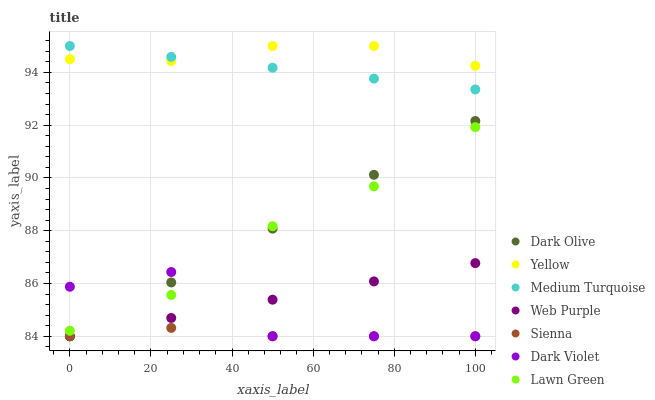Does Sienna have the minimum area under the curve?
Answer yes or no. Yes. Does Yellow have the maximum area under the curve?
Answer yes or no. Yes. Does Dark Olive have the minimum area under the curve?
Answer yes or no. No. Does Dark Olive have the maximum area under the curve?
Answer yes or no. No. Is Dark Olive the smoothest?
Answer yes or no. Yes. Is Dark Violet the roughest?
Answer yes or no. Yes. Is Dark Violet the smoothest?
Answer yes or no. No. Is Dark Olive the roughest?
Answer yes or no. No. Does Dark Olive have the lowest value?
Answer yes or no. Yes. Does Yellow have the lowest value?
Answer yes or no. No. Does Medium Turquoise have the highest value?
Answer yes or no. Yes. Does Dark Olive have the highest value?
Answer yes or no. No. Is Web Purple less than Yellow?
Answer yes or no. Yes. Is Medium Turquoise greater than Web Purple?
Answer yes or no. Yes. Does Lawn Green intersect Dark Violet?
Answer yes or no. Yes. Is Lawn Green less than Dark Violet?
Answer yes or no. No. Is Lawn Green greater than Dark Violet?
Answer yes or no. No. Does Web Purple intersect Yellow?
Answer yes or no. No. 